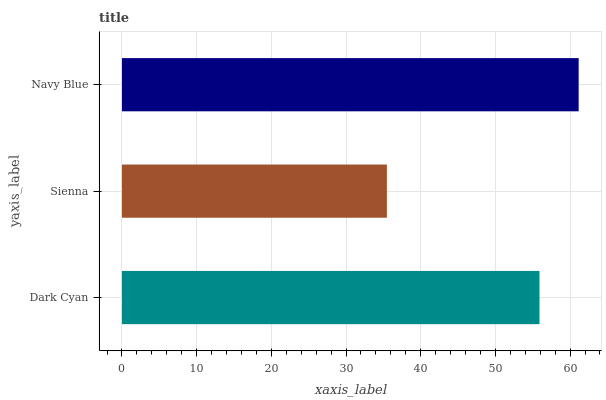Is Sienna the minimum?
Answer yes or no. Yes. Is Navy Blue the maximum?
Answer yes or no. Yes. Is Navy Blue the minimum?
Answer yes or no. No. Is Sienna the maximum?
Answer yes or no. No. Is Navy Blue greater than Sienna?
Answer yes or no. Yes. Is Sienna less than Navy Blue?
Answer yes or no. Yes. Is Sienna greater than Navy Blue?
Answer yes or no. No. Is Navy Blue less than Sienna?
Answer yes or no. No. Is Dark Cyan the high median?
Answer yes or no. Yes. Is Dark Cyan the low median?
Answer yes or no. Yes. Is Navy Blue the high median?
Answer yes or no. No. Is Sienna the low median?
Answer yes or no. No. 